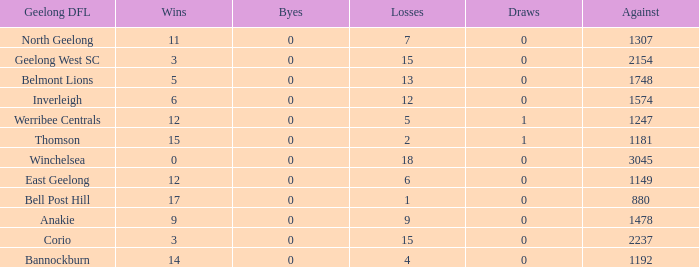What is the lowest number of wins where the losses are more than 12 and the draws are less than 0? None. 